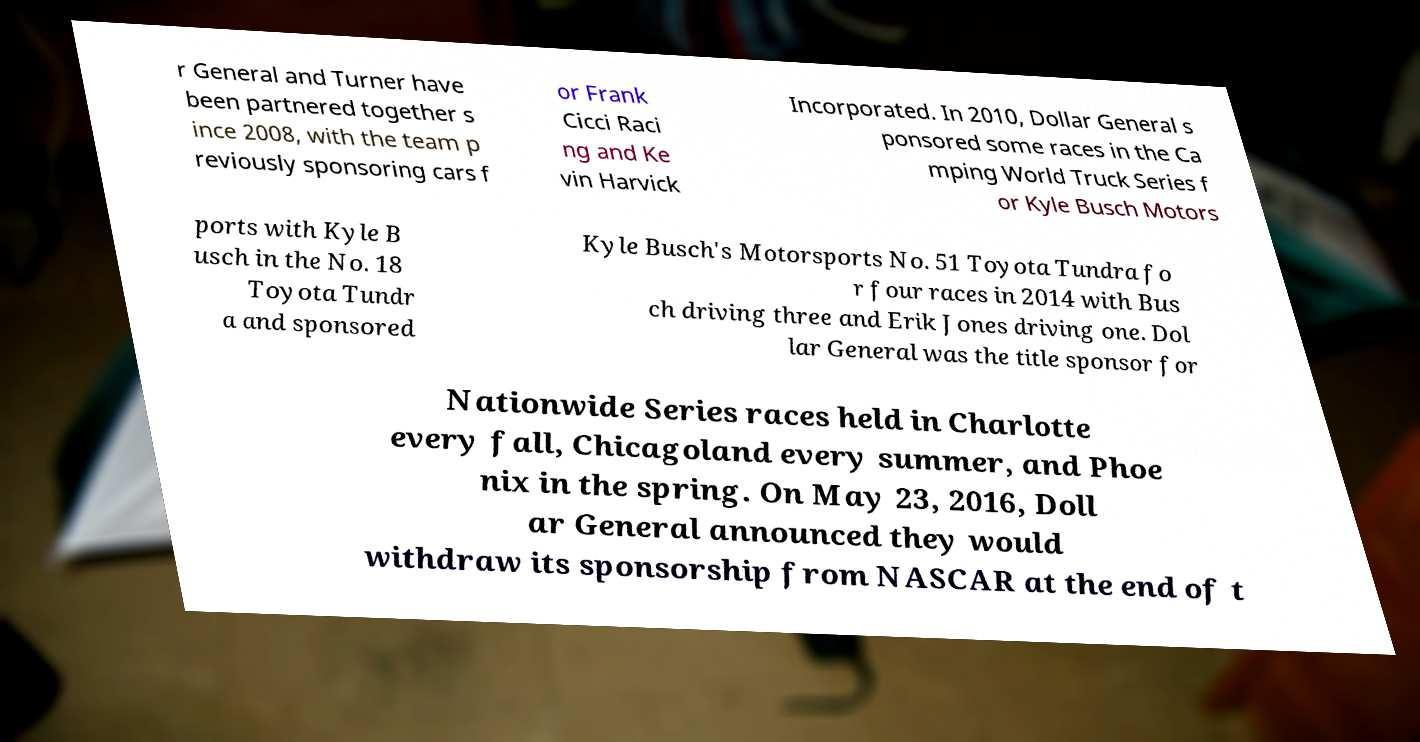What messages or text are displayed in this image? I need them in a readable, typed format. r General and Turner have been partnered together s ince 2008, with the team p reviously sponsoring cars f or Frank Cicci Raci ng and Ke vin Harvick Incorporated. In 2010, Dollar General s ponsored some races in the Ca mping World Truck Series f or Kyle Busch Motors ports with Kyle B usch in the No. 18 Toyota Tundr a and sponsored Kyle Busch's Motorsports No. 51 Toyota Tundra fo r four races in 2014 with Bus ch driving three and Erik Jones driving one. Dol lar General was the title sponsor for Nationwide Series races held in Charlotte every fall, Chicagoland every summer, and Phoe nix in the spring. On May 23, 2016, Doll ar General announced they would withdraw its sponsorship from NASCAR at the end of t 